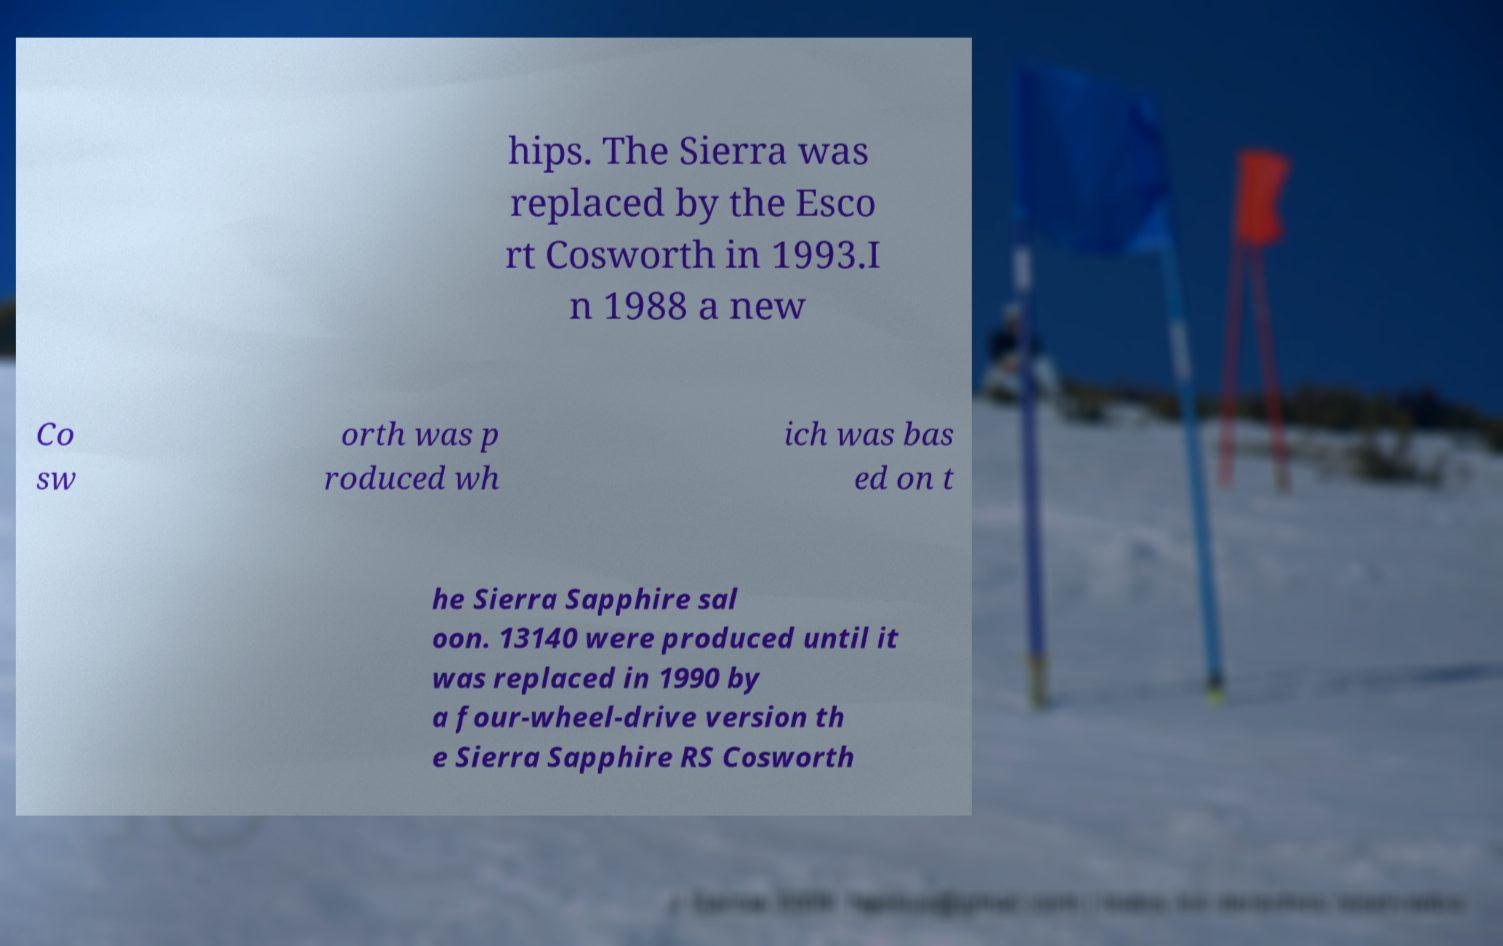There's text embedded in this image that I need extracted. Can you transcribe it verbatim? hips. The Sierra was replaced by the Esco rt Cosworth in 1993.I n 1988 a new Co sw orth was p roduced wh ich was bas ed on t he Sierra Sapphire sal oon. 13140 were produced until it was replaced in 1990 by a four-wheel-drive version th e Sierra Sapphire RS Cosworth 